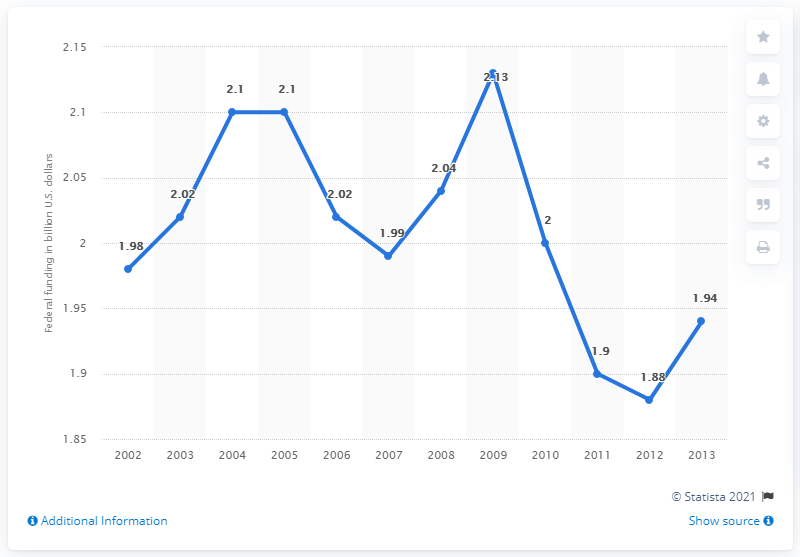List a handful of essential elements in this visual. In the year 2013, the federal funding for arts and culture was 1.94 million dollars. In the year 2009, the deflated federal arts and culture funding in the United States was 2.13. In the year 2006 and 2008, the value of funding differed by 0.02. 